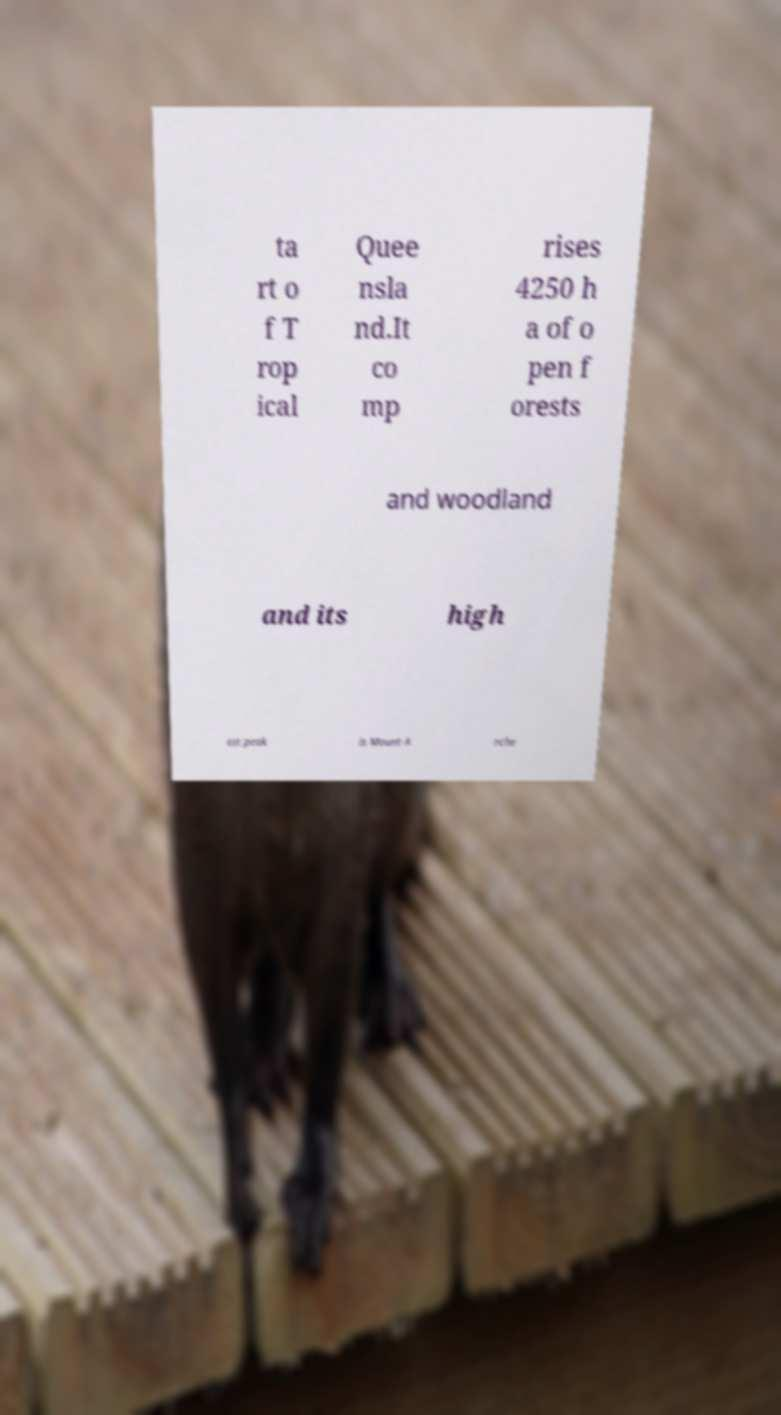Can you accurately transcribe the text from the provided image for me? ta rt o f T rop ical Quee nsla nd.It co mp rises 4250 h a of o pen f orests and woodland and its high est peak is Mount A rche 